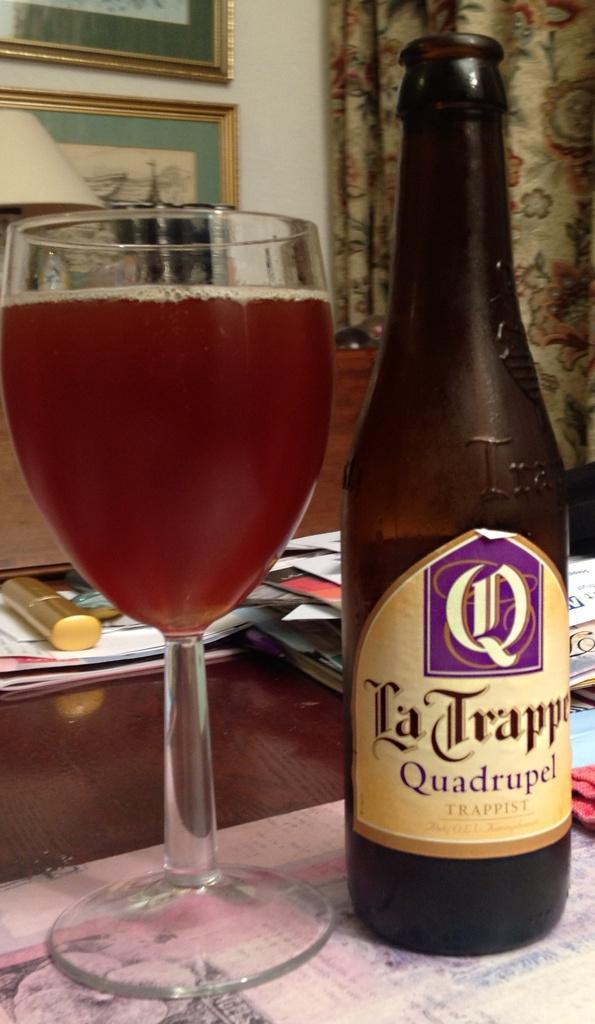In one or two sentences, can you explain what this image depicts? In this image, we can see a wine glass with liquid. Beside the glass there is a bottle with sticker is placed on the surface. Background we can see few books, some objects, wall, photo frames, curtain. 